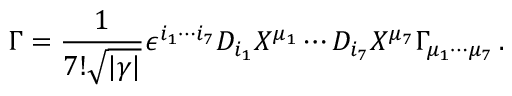Convert formula to latex. <formula><loc_0><loc_0><loc_500><loc_500>\Gamma = { \frac { 1 } { 7 ! \sqrt { | \gamma | } } } \epsilon ^ { i _ { 1 } \cdots i _ { 7 } } D _ { i _ { 1 } } X ^ { \mu _ { 1 } } \cdots D _ { i _ { 7 } } X ^ { \mu _ { 7 } } \Gamma _ { \mu _ { 1 } \cdots \mu _ { 7 } } \, .</formula> 